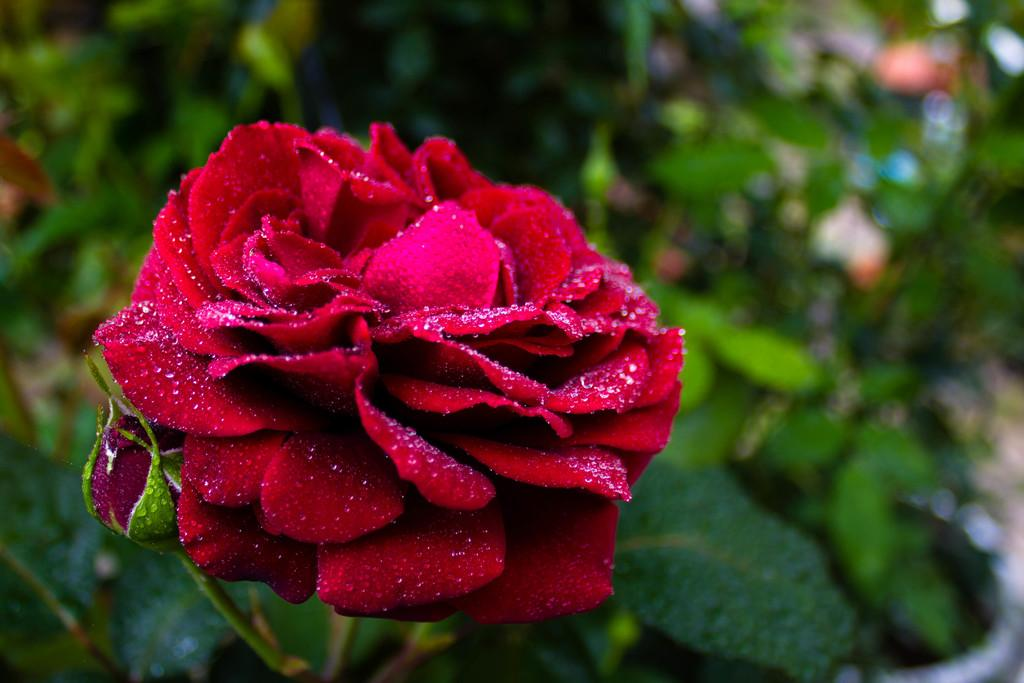What type of flower is present in the image? There is a rose flower in the image. Can you describe the stage of the rose in the image? There is a rose bud in the image. How would you characterize the background of the image? The background of the image is blurred. What type of bait is used to catch fish in the image? There is no bait or fishing activity present in the image; it features a rose flower and a rose bud. How many eggs are visible in the image? There are no eggs present in the image. 